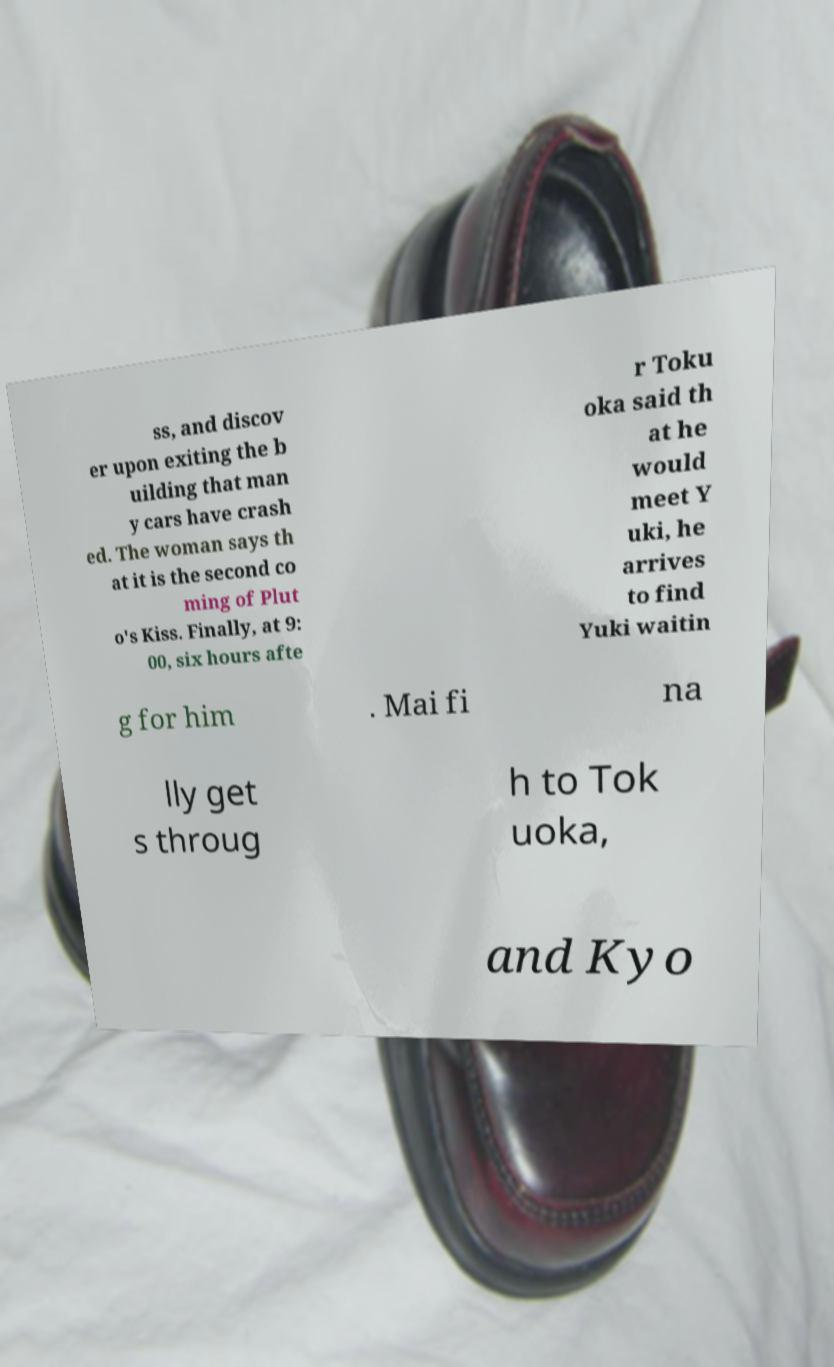Can you accurately transcribe the text from the provided image for me? ss, and discov er upon exiting the b uilding that man y cars have crash ed. The woman says th at it is the second co ming of Plut o's Kiss. Finally, at 9: 00, six hours afte r Toku oka said th at he would meet Y uki, he arrives to find Yuki waitin g for him . Mai fi na lly get s throug h to Tok uoka, and Kyo 